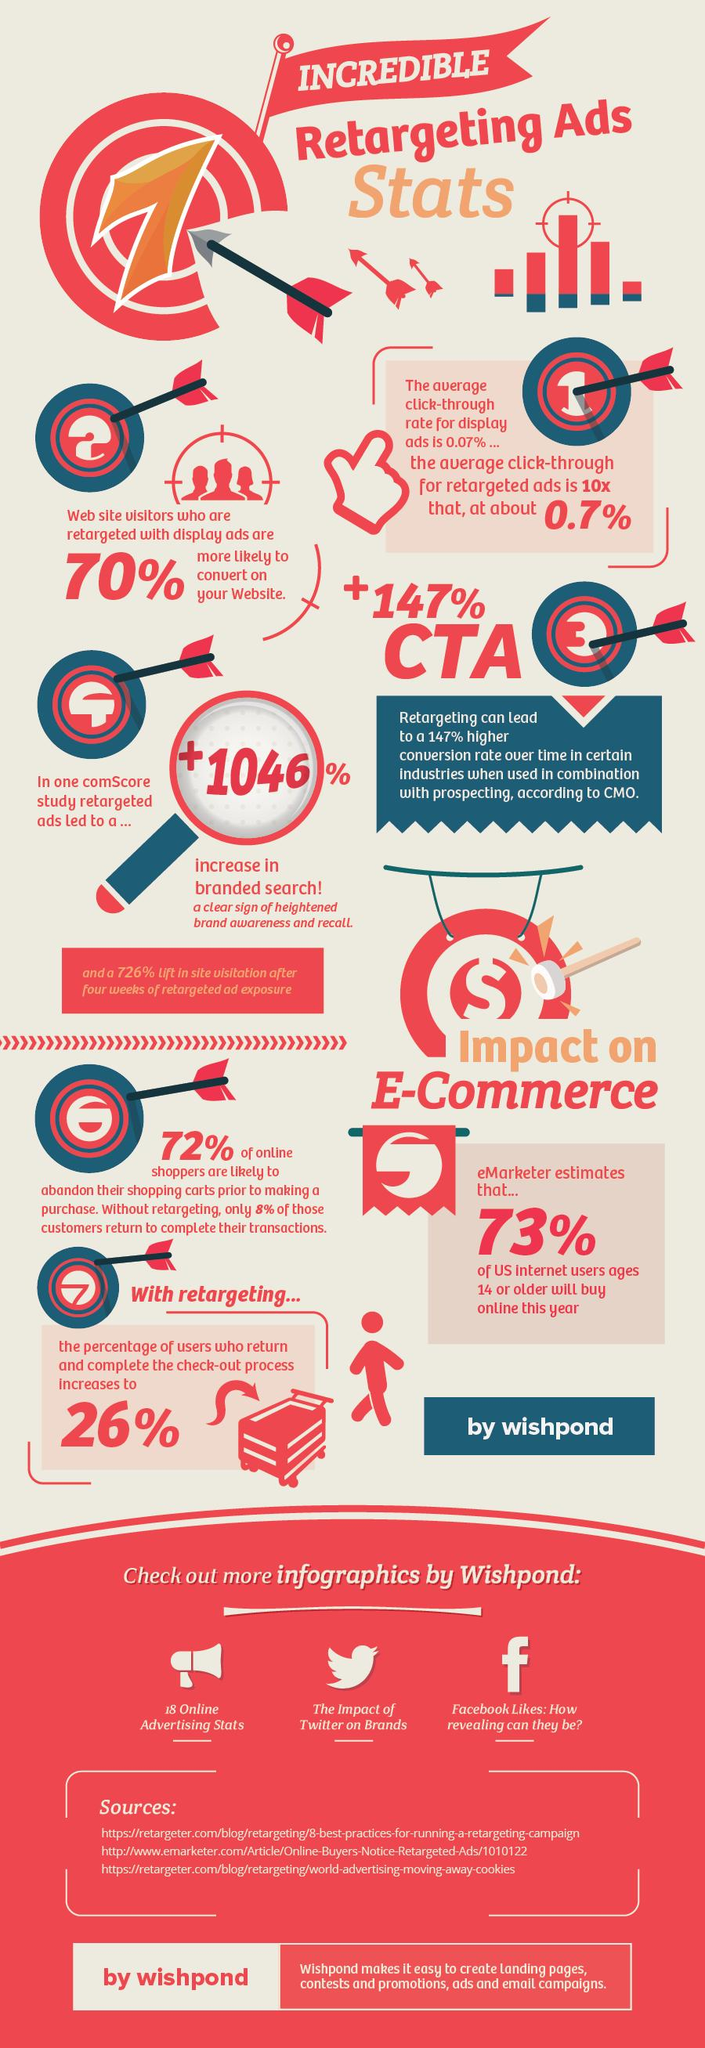Point out several critical features in this image. The infographic contains 9 arrows. 